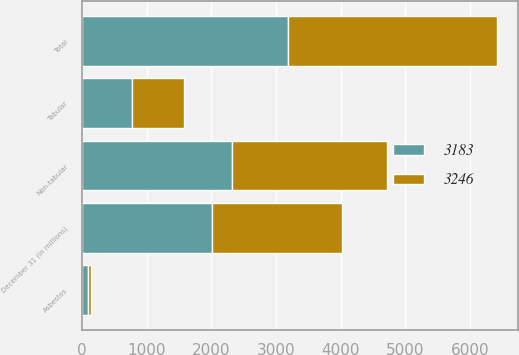<chart> <loc_0><loc_0><loc_500><loc_500><stacked_bar_chart><ecel><fcel>December 31 (in millions)<fcel>Tabular<fcel>Non-tabular<fcel>Asbestos<fcel>Total<nl><fcel>3246<fcel>2012<fcel>801<fcel>2394<fcel>51<fcel>3246<nl><fcel>3183<fcel>2011<fcel>777<fcel>2318<fcel>88<fcel>3183<nl></chart> 